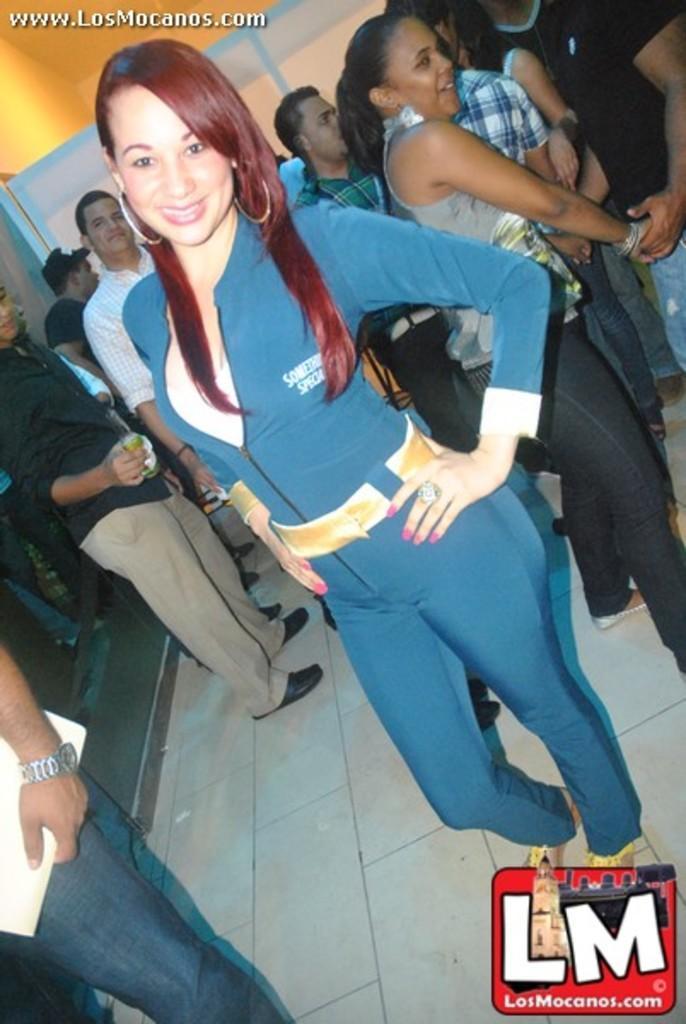How would you summarize this image in a sentence or two? In the image we can see the people standing, wearing clothes and some of them are wearing shoes and they are smiling. On the bottom right and top left, we can see the watermark. 